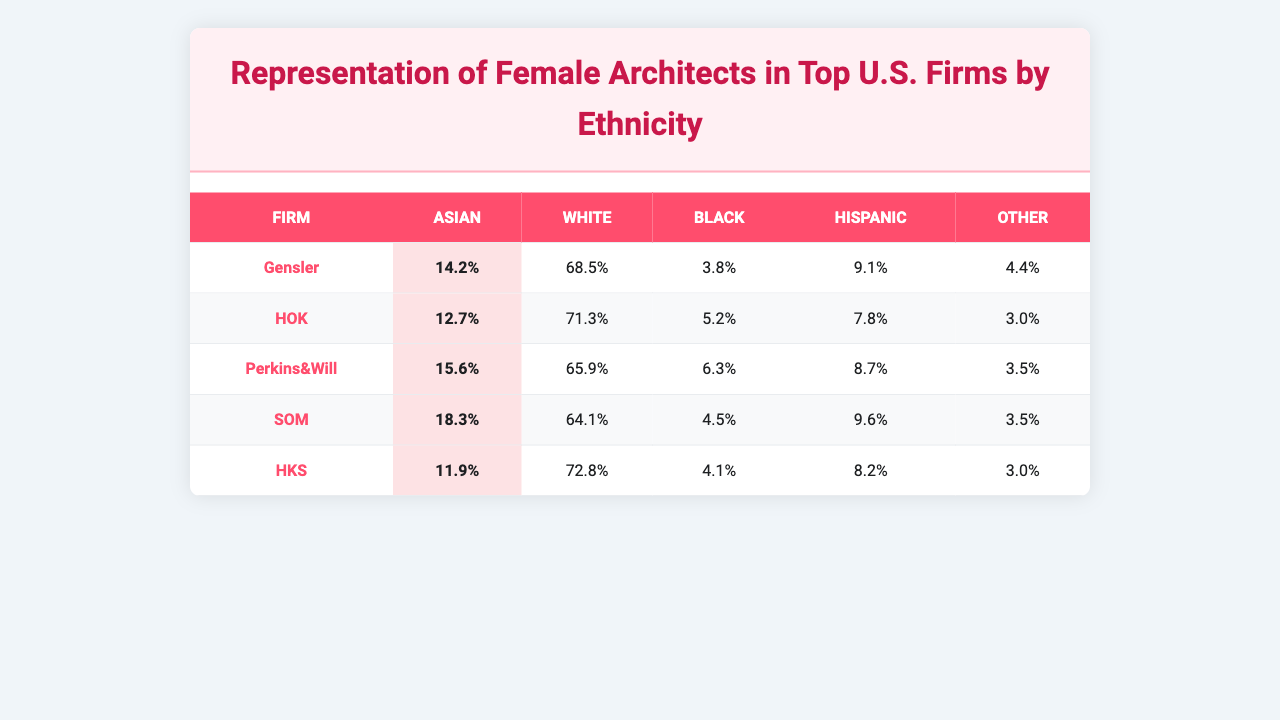What percentage of female architects at Gensler are Asian? According to the table, the percentage of female architects at Gensler who are Asian is listed as 14.2%.
Answer: 14.2% Which firm has the highest percentage of Black female architects? The firm with the highest percentage of Black female architects is Perkins&Will, with 6.3%.
Answer: 6.3% What is the average percentage of White female architects across all firms? To calculate the average percentage of White female architects, we sum the percentages: (68.5 + 71.3 + 65.9 + 64.1 + 72.8) = 342.6. Dividing by the number of firms (5) gives us an average of 342.6 / 5 = 68.52%.
Answer: 68.52% Is the percentage of Hispanic female architects at HOK higher than at HKS? The percentage of Hispanic female architects at HOK is 7.8%, while at HKS it is 8.2%. Since 7.8% is less than 8.2%, the statement is false.
Answer: No Which firm has the lowest percentage of Asian female architects? The firm with the lowest percentage of Asian female architects is HKS, with 11.9%.
Answer: 11.9% What is the difference between the percentage of Other female architects at Perkins&Will and Gensler? The percentage of Other female architects at Perkins&Will is 3.5%, and for Gensler, it is 4.4%. The difference is calculated as 4.4% - 3.5% = 0.9%.
Answer: 0.9% If we consider only Asian and Black female architects, which firm has the highest combined percentage? To find the firm with the highest combined percentage of Asian and Black female architects, we add the percentages for each firm: Gensler (14.2 + 3.8 = 18.0), HOK (12.7 + 5.2 = 17.9), Perkins&Will (15.6 + 6.3 = 21.9), SOM (18.3 + 4.5 = 22.8), HKS (11.9 + 4.1 = 16.0). The firm with the highest combined percentage is SOM with 22.8%.
Answer: 22.8% Which ethnicity has the lowest representation among female architects at Perkins&Will? At Perkins&Will, the ethnicity with the lowest representation is Other, accounting for 3.5%.
Answer: Other Which firm has a higher percentage of Hispanic female architects, Perkins&Will or SOM? The percentage of Hispanic female architects at Perkins&Will is 8.7%, while at SOM it is 9.6%. Since 8.7% is less than 9.6%, SOM has a higher percentage.
Answer: SOM What is the total percentage of female architects categorized as 'Other' across all firms? The total percentage of female architects categorized as 'Other' is calculated by summing the percentages for each firm: (4.4 + 3.0 + 3.5 + 3.5 + 3.0) = 17.4%.
Answer: 17.4% 